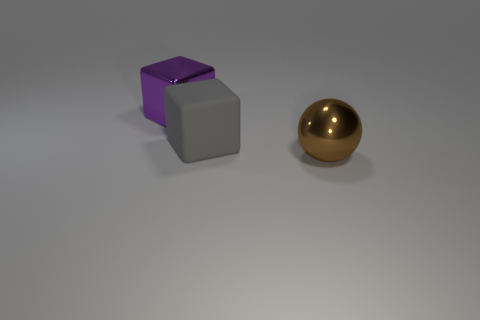Subtract all green blocks. Subtract all blue cylinders. How many blocks are left? 2 Add 1 large red metallic balls. How many objects exist? 4 Subtract all spheres. How many objects are left? 2 Add 3 large gray things. How many large gray things exist? 4 Subtract 0 yellow blocks. How many objects are left? 3 Subtract all big spheres. Subtract all large gray matte things. How many objects are left? 1 Add 3 balls. How many balls are left? 4 